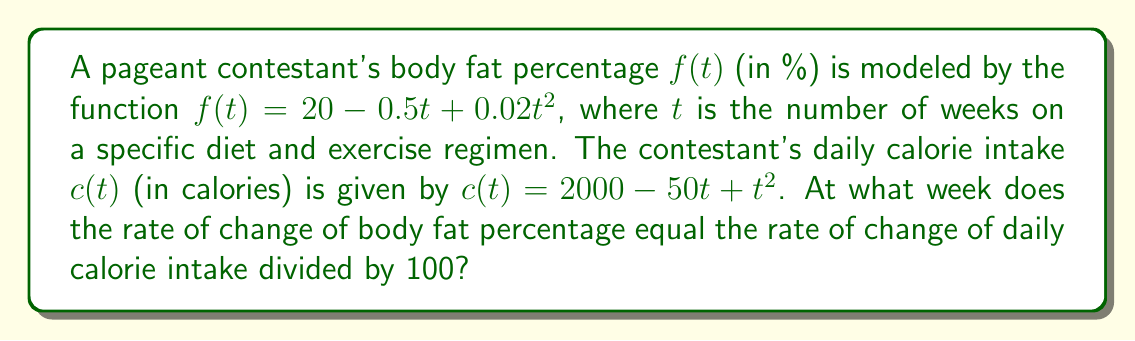Show me your answer to this math problem. To solve this problem, we need to follow these steps:

1) First, we need to find the derivatives of both functions:

   For body fat percentage: $f'(t) = \frac{d}{dt}(20 - 0.5t + 0.02t^2) = -0.5 + 0.04t$
   
   For daily calorie intake: $c'(t) = \frac{d}{dt}(2000 - 50t + t^2) = -50 + 2t$

2) We're asked to find when the rate of change of body fat percentage equals the rate of change of daily calorie intake divided by 100. This can be expressed as:

   $f'(t) = \frac{c'(t)}{100}$

3) Let's substitute the derivatives we found:

   $-0.5 + 0.04t = \frac{-50 + 2t}{100}$

4) Simplify the right side:

   $-0.5 + 0.04t = -0.5 + 0.02t$

5) Now we can solve this equation:

   $0.04t = 0.02t$
   $0.02t = 0$
   $t = 0$

6) Therefore, the rate of change of body fat percentage equals the rate of change of daily calorie intake divided by 100 at week 0, which is the start of the diet and exercise regimen.
Answer: 0 weeks 